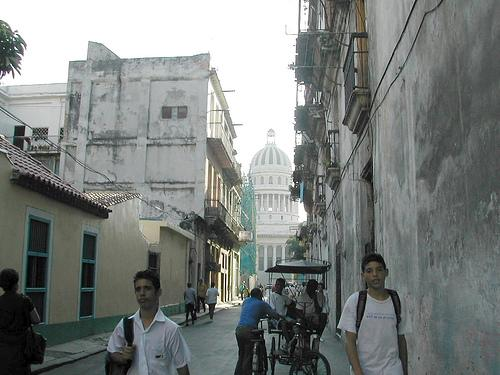Who is closest to the wall? Please explain your reasoning. boy. A young guy is walking on a sidewalk next to a building. 